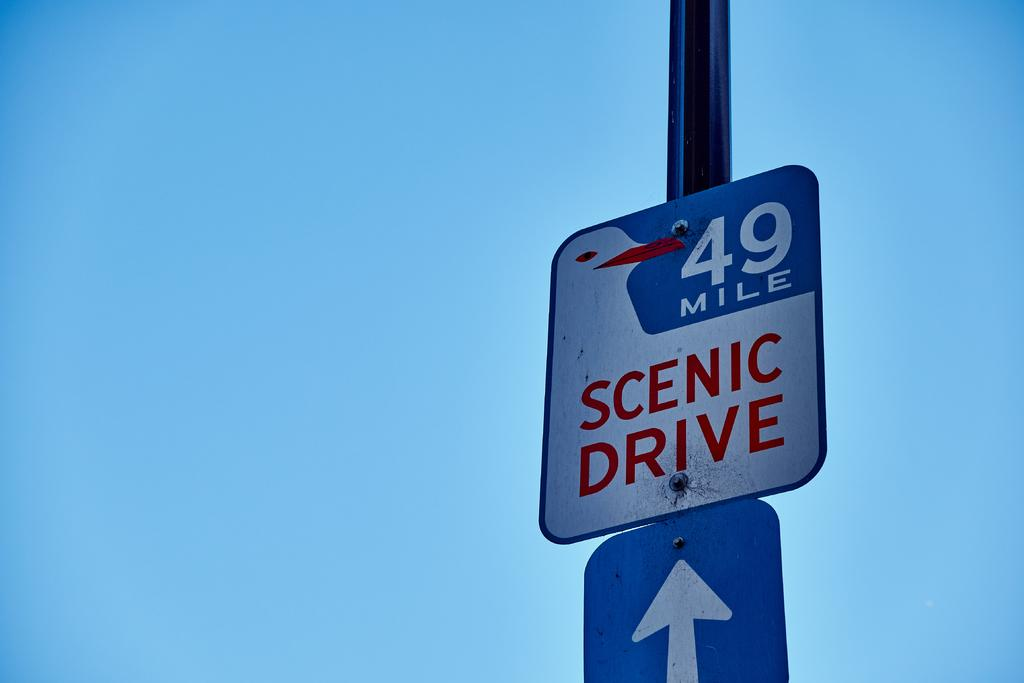<image>
Write a terse but informative summary of the picture. A 49 Mile Scenic Drive sign sits above a white arrow, against a backdrop of a bright blue sky. 